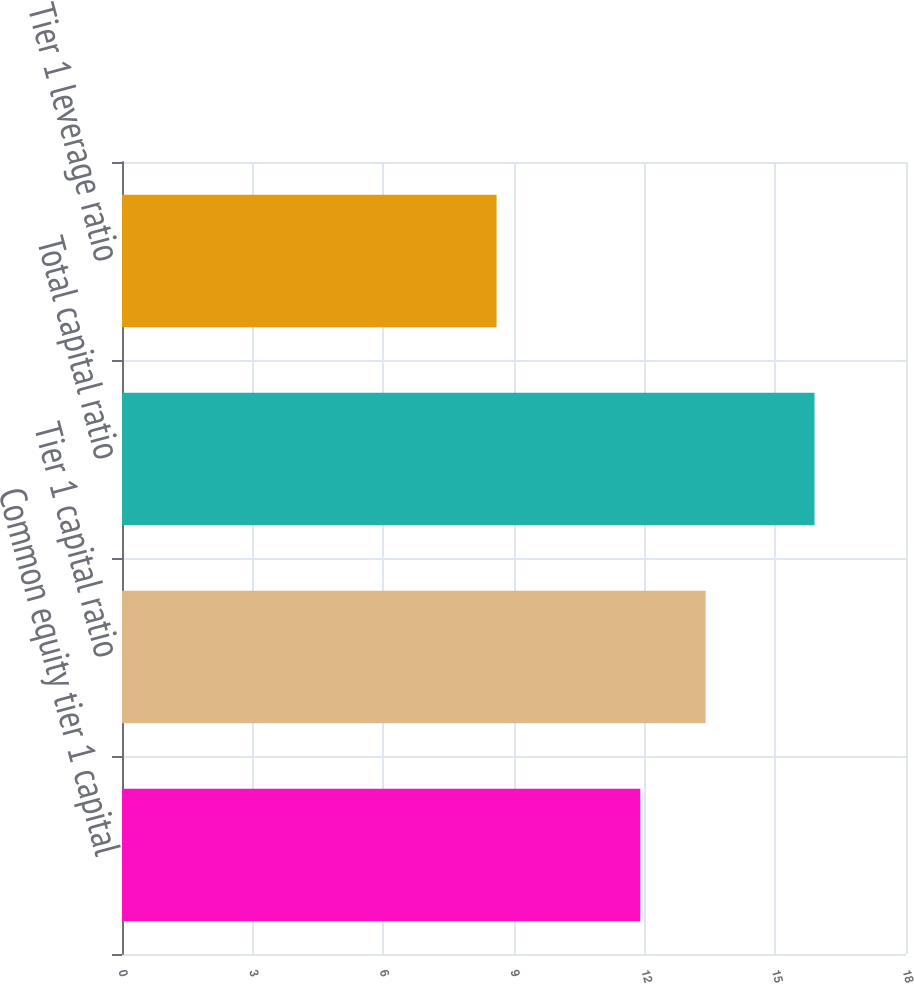Convert chart to OTSL. <chart><loc_0><loc_0><loc_500><loc_500><bar_chart><fcel>Common equity tier 1 capital<fcel>Tier 1 capital ratio<fcel>Total capital ratio<fcel>Tier 1 leverage ratio<nl><fcel>11.9<fcel>13.4<fcel>15.9<fcel>8.6<nl></chart> 